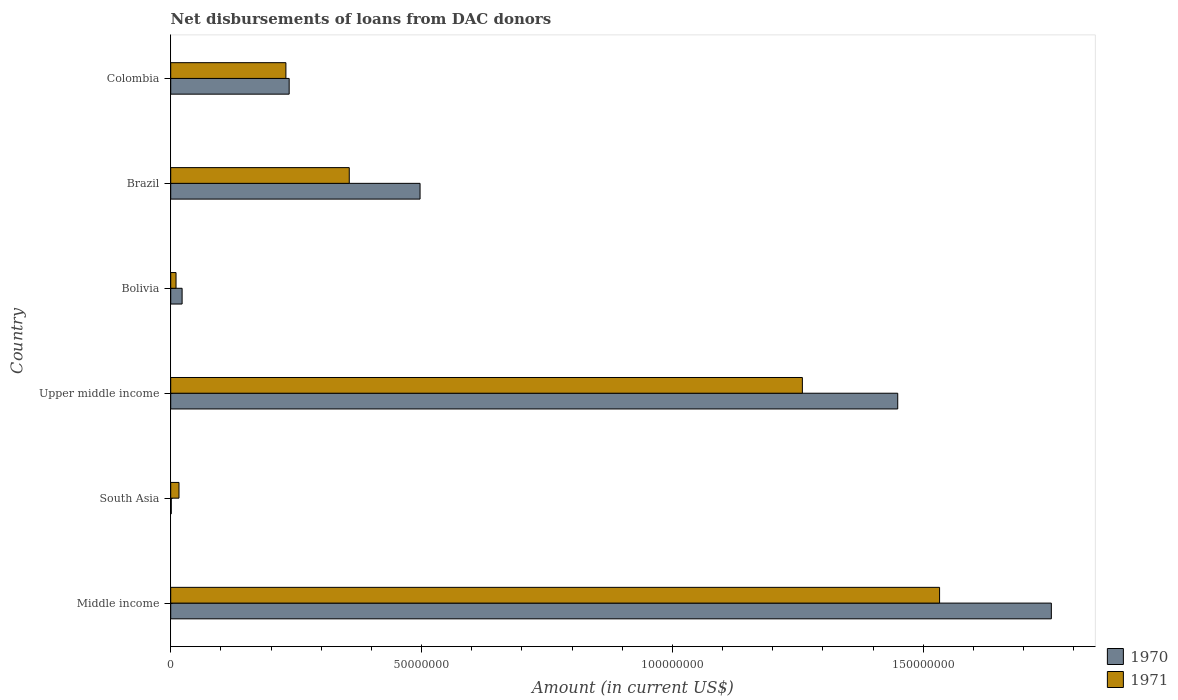How many groups of bars are there?
Offer a very short reply. 6. How many bars are there on the 3rd tick from the top?
Ensure brevity in your answer.  2. How many bars are there on the 1st tick from the bottom?
Provide a short and direct response. 2. What is the amount of loans disbursed in 1970 in South Asia?
Make the answer very short. 1.09e+05. Across all countries, what is the maximum amount of loans disbursed in 1970?
Keep it short and to the point. 1.76e+08. Across all countries, what is the minimum amount of loans disbursed in 1971?
Ensure brevity in your answer.  1.06e+06. What is the total amount of loans disbursed in 1970 in the graph?
Make the answer very short. 3.96e+08. What is the difference between the amount of loans disbursed in 1970 in Brazil and that in Colombia?
Your response must be concise. 2.61e+07. What is the difference between the amount of loans disbursed in 1971 in Brazil and the amount of loans disbursed in 1970 in Upper middle income?
Your answer should be very brief. -1.09e+08. What is the average amount of loans disbursed in 1970 per country?
Offer a terse response. 6.60e+07. What is the difference between the amount of loans disbursed in 1970 and amount of loans disbursed in 1971 in Upper middle income?
Your response must be concise. 1.90e+07. What is the ratio of the amount of loans disbursed in 1971 in Colombia to that in Middle income?
Offer a terse response. 0.15. Is the difference between the amount of loans disbursed in 1970 in Bolivia and Brazil greater than the difference between the amount of loans disbursed in 1971 in Bolivia and Brazil?
Give a very brief answer. No. What is the difference between the highest and the second highest amount of loans disbursed in 1970?
Your response must be concise. 3.06e+07. What is the difference between the highest and the lowest amount of loans disbursed in 1971?
Keep it short and to the point. 1.52e+08. Is the sum of the amount of loans disbursed in 1970 in Bolivia and Colombia greater than the maximum amount of loans disbursed in 1971 across all countries?
Keep it short and to the point. No. Are all the bars in the graph horizontal?
Your answer should be very brief. Yes. How many countries are there in the graph?
Offer a very short reply. 6. What is the difference between two consecutive major ticks on the X-axis?
Your response must be concise. 5.00e+07. Does the graph contain any zero values?
Your answer should be very brief. No. How many legend labels are there?
Offer a terse response. 2. What is the title of the graph?
Your answer should be very brief. Net disbursements of loans from DAC donors. What is the Amount (in current US$) of 1970 in Middle income?
Provide a short and direct response. 1.76e+08. What is the Amount (in current US$) in 1971 in Middle income?
Ensure brevity in your answer.  1.53e+08. What is the Amount (in current US$) of 1970 in South Asia?
Provide a succinct answer. 1.09e+05. What is the Amount (in current US$) in 1971 in South Asia?
Your answer should be compact. 1.65e+06. What is the Amount (in current US$) in 1970 in Upper middle income?
Your answer should be compact. 1.45e+08. What is the Amount (in current US$) of 1971 in Upper middle income?
Your response must be concise. 1.26e+08. What is the Amount (in current US$) in 1970 in Bolivia?
Offer a very short reply. 2.27e+06. What is the Amount (in current US$) of 1971 in Bolivia?
Give a very brief answer. 1.06e+06. What is the Amount (in current US$) in 1970 in Brazil?
Offer a terse response. 4.97e+07. What is the Amount (in current US$) in 1971 in Brazil?
Offer a terse response. 3.56e+07. What is the Amount (in current US$) in 1970 in Colombia?
Give a very brief answer. 2.36e+07. What is the Amount (in current US$) of 1971 in Colombia?
Ensure brevity in your answer.  2.30e+07. Across all countries, what is the maximum Amount (in current US$) in 1970?
Ensure brevity in your answer.  1.76e+08. Across all countries, what is the maximum Amount (in current US$) of 1971?
Keep it short and to the point. 1.53e+08. Across all countries, what is the minimum Amount (in current US$) of 1970?
Offer a very short reply. 1.09e+05. Across all countries, what is the minimum Amount (in current US$) of 1971?
Your answer should be compact. 1.06e+06. What is the total Amount (in current US$) of 1970 in the graph?
Your answer should be very brief. 3.96e+08. What is the total Amount (in current US$) in 1971 in the graph?
Provide a succinct answer. 3.40e+08. What is the difference between the Amount (in current US$) of 1970 in Middle income and that in South Asia?
Give a very brief answer. 1.75e+08. What is the difference between the Amount (in current US$) of 1971 in Middle income and that in South Asia?
Offer a very short reply. 1.52e+08. What is the difference between the Amount (in current US$) in 1970 in Middle income and that in Upper middle income?
Offer a terse response. 3.06e+07. What is the difference between the Amount (in current US$) in 1971 in Middle income and that in Upper middle income?
Give a very brief answer. 2.74e+07. What is the difference between the Amount (in current US$) of 1970 in Middle income and that in Bolivia?
Your answer should be very brief. 1.73e+08. What is the difference between the Amount (in current US$) in 1971 in Middle income and that in Bolivia?
Offer a terse response. 1.52e+08. What is the difference between the Amount (in current US$) of 1970 in Middle income and that in Brazil?
Keep it short and to the point. 1.26e+08. What is the difference between the Amount (in current US$) in 1971 in Middle income and that in Brazil?
Your answer should be compact. 1.18e+08. What is the difference between the Amount (in current US$) in 1970 in Middle income and that in Colombia?
Offer a terse response. 1.52e+08. What is the difference between the Amount (in current US$) of 1971 in Middle income and that in Colombia?
Offer a terse response. 1.30e+08. What is the difference between the Amount (in current US$) of 1970 in South Asia and that in Upper middle income?
Provide a short and direct response. -1.45e+08. What is the difference between the Amount (in current US$) of 1971 in South Asia and that in Upper middle income?
Make the answer very short. -1.24e+08. What is the difference between the Amount (in current US$) in 1970 in South Asia and that in Bolivia?
Keep it short and to the point. -2.16e+06. What is the difference between the Amount (in current US$) in 1971 in South Asia and that in Bolivia?
Give a very brief answer. 5.92e+05. What is the difference between the Amount (in current US$) in 1970 in South Asia and that in Brazil?
Offer a terse response. -4.96e+07. What is the difference between the Amount (in current US$) in 1971 in South Asia and that in Brazil?
Ensure brevity in your answer.  -3.39e+07. What is the difference between the Amount (in current US$) in 1970 in South Asia and that in Colombia?
Ensure brevity in your answer.  -2.35e+07. What is the difference between the Amount (in current US$) of 1971 in South Asia and that in Colombia?
Give a very brief answer. -2.13e+07. What is the difference between the Amount (in current US$) of 1970 in Upper middle income and that in Bolivia?
Your answer should be very brief. 1.43e+08. What is the difference between the Amount (in current US$) of 1971 in Upper middle income and that in Bolivia?
Offer a very short reply. 1.25e+08. What is the difference between the Amount (in current US$) in 1970 in Upper middle income and that in Brazil?
Offer a very short reply. 9.52e+07. What is the difference between the Amount (in current US$) in 1971 in Upper middle income and that in Brazil?
Provide a succinct answer. 9.03e+07. What is the difference between the Amount (in current US$) in 1970 in Upper middle income and that in Colombia?
Your response must be concise. 1.21e+08. What is the difference between the Amount (in current US$) in 1971 in Upper middle income and that in Colombia?
Your response must be concise. 1.03e+08. What is the difference between the Amount (in current US$) of 1970 in Bolivia and that in Brazil?
Provide a short and direct response. -4.74e+07. What is the difference between the Amount (in current US$) in 1971 in Bolivia and that in Brazil?
Provide a short and direct response. -3.45e+07. What is the difference between the Amount (in current US$) in 1970 in Bolivia and that in Colombia?
Provide a succinct answer. -2.13e+07. What is the difference between the Amount (in current US$) of 1971 in Bolivia and that in Colombia?
Offer a very short reply. -2.19e+07. What is the difference between the Amount (in current US$) in 1970 in Brazil and that in Colombia?
Give a very brief answer. 2.61e+07. What is the difference between the Amount (in current US$) of 1971 in Brazil and that in Colombia?
Your response must be concise. 1.26e+07. What is the difference between the Amount (in current US$) in 1970 in Middle income and the Amount (in current US$) in 1971 in South Asia?
Offer a terse response. 1.74e+08. What is the difference between the Amount (in current US$) of 1970 in Middle income and the Amount (in current US$) of 1971 in Upper middle income?
Offer a terse response. 4.96e+07. What is the difference between the Amount (in current US$) in 1970 in Middle income and the Amount (in current US$) in 1971 in Bolivia?
Keep it short and to the point. 1.74e+08. What is the difference between the Amount (in current US$) in 1970 in Middle income and the Amount (in current US$) in 1971 in Brazil?
Your answer should be compact. 1.40e+08. What is the difference between the Amount (in current US$) in 1970 in Middle income and the Amount (in current US$) in 1971 in Colombia?
Your response must be concise. 1.53e+08. What is the difference between the Amount (in current US$) in 1970 in South Asia and the Amount (in current US$) in 1971 in Upper middle income?
Keep it short and to the point. -1.26e+08. What is the difference between the Amount (in current US$) of 1970 in South Asia and the Amount (in current US$) of 1971 in Bolivia?
Make the answer very short. -9.49e+05. What is the difference between the Amount (in current US$) of 1970 in South Asia and the Amount (in current US$) of 1971 in Brazil?
Make the answer very short. -3.55e+07. What is the difference between the Amount (in current US$) of 1970 in South Asia and the Amount (in current US$) of 1971 in Colombia?
Your answer should be compact. -2.29e+07. What is the difference between the Amount (in current US$) in 1970 in Upper middle income and the Amount (in current US$) in 1971 in Bolivia?
Offer a terse response. 1.44e+08. What is the difference between the Amount (in current US$) of 1970 in Upper middle income and the Amount (in current US$) of 1971 in Brazil?
Ensure brevity in your answer.  1.09e+08. What is the difference between the Amount (in current US$) in 1970 in Upper middle income and the Amount (in current US$) in 1971 in Colombia?
Ensure brevity in your answer.  1.22e+08. What is the difference between the Amount (in current US$) in 1970 in Bolivia and the Amount (in current US$) in 1971 in Brazil?
Provide a succinct answer. -3.33e+07. What is the difference between the Amount (in current US$) of 1970 in Bolivia and the Amount (in current US$) of 1971 in Colombia?
Provide a short and direct response. -2.07e+07. What is the difference between the Amount (in current US$) of 1970 in Brazil and the Amount (in current US$) of 1971 in Colombia?
Your answer should be compact. 2.67e+07. What is the average Amount (in current US$) of 1970 per country?
Your answer should be compact. 6.60e+07. What is the average Amount (in current US$) of 1971 per country?
Give a very brief answer. 5.67e+07. What is the difference between the Amount (in current US$) of 1970 and Amount (in current US$) of 1971 in Middle income?
Your answer should be compact. 2.23e+07. What is the difference between the Amount (in current US$) in 1970 and Amount (in current US$) in 1971 in South Asia?
Offer a very short reply. -1.54e+06. What is the difference between the Amount (in current US$) of 1970 and Amount (in current US$) of 1971 in Upper middle income?
Give a very brief answer. 1.90e+07. What is the difference between the Amount (in current US$) in 1970 and Amount (in current US$) in 1971 in Bolivia?
Offer a very short reply. 1.21e+06. What is the difference between the Amount (in current US$) in 1970 and Amount (in current US$) in 1971 in Brazil?
Your answer should be compact. 1.41e+07. What is the difference between the Amount (in current US$) of 1970 and Amount (in current US$) of 1971 in Colombia?
Keep it short and to the point. 6.52e+05. What is the ratio of the Amount (in current US$) of 1970 in Middle income to that in South Asia?
Offer a terse response. 1610.58. What is the ratio of the Amount (in current US$) in 1971 in Middle income to that in South Asia?
Offer a terse response. 92.89. What is the ratio of the Amount (in current US$) of 1970 in Middle income to that in Upper middle income?
Ensure brevity in your answer.  1.21. What is the ratio of the Amount (in current US$) in 1971 in Middle income to that in Upper middle income?
Your answer should be very brief. 1.22. What is the ratio of the Amount (in current US$) of 1970 in Middle income to that in Bolivia?
Make the answer very short. 77.34. What is the ratio of the Amount (in current US$) of 1971 in Middle income to that in Bolivia?
Provide a short and direct response. 144.87. What is the ratio of the Amount (in current US$) of 1970 in Middle income to that in Brazil?
Provide a succinct answer. 3.53. What is the ratio of the Amount (in current US$) of 1971 in Middle income to that in Brazil?
Your response must be concise. 4.31. What is the ratio of the Amount (in current US$) in 1970 in Middle income to that in Colombia?
Provide a short and direct response. 7.43. What is the ratio of the Amount (in current US$) of 1971 in Middle income to that in Colombia?
Make the answer very short. 6.67. What is the ratio of the Amount (in current US$) in 1970 in South Asia to that in Upper middle income?
Your answer should be very brief. 0. What is the ratio of the Amount (in current US$) in 1971 in South Asia to that in Upper middle income?
Provide a short and direct response. 0.01. What is the ratio of the Amount (in current US$) in 1970 in South Asia to that in Bolivia?
Your answer should be compact. 0.05. What is the ratio of the Amount (in current US$) of 1971 in South Asia to that in Bolivia?
Ensure brevity in your answer.  1.56. What is the ratio of the Amount (in current US$) in 1970 in South Asia to that in Brazil?
Offer a terse response. 0. What is the ratio of the Amount (in current US$) in 1971 in South Asia to that in Brazil?
Provide a short and direct response. 0.05. What is the ratio of the Amount (in current US$) of 1970 in South Asia to that in Colombia?
Keep it short and to the point. 0. What is the ratio of the Amount (in current US$) in 1971 in South Asia to that in Colombia?
Ensure brevity in your answer.  0.07. What is the ratio of the Amount (in current US$) in 1970 in Upper middle income to that in Bolivia?
Ensure brevity in your answer.  63.85. What is the ratio of the Amount (in current US$) in 1971 in Upper middle income to that in Bolivia?
Provide a short and direct response. 119.02. What is the ratio of the Amount (in current US$) of 1970 in Upper middle income to that in Brazil?
Make the answer very short. 2.92. What is the ratio of the Amount (in current US$) in 1971 in Upper middle income to that in Brazil?
Ensure brevity in your answer.  3.54. What is the ratio of the Amount (in current US$) of 1970 in Upper middle income to that in Colombia?
Provide a succinct answer. 6.14. What is the ratio of the Amount (in current US$) in 1971 in Upper middle income to that in Colombia?
Make the answer very short. 5.48. What is the ratio of the Amount (in current US$) in 1970 in Bolivia to that in Brazil?
Your response must be concise. 0.05. What is the ratio of the Amount (in current US$) of 1971 in Bolivia to that in Brazil?
Offer a very short reply. 0.03. What is the ratio of the Amount (in current US$) in 1970 in Bolivia to that in Colombia?
Provide a succinct answer. 0.1. What is the ratio of the Amount (in current US$) of 1971 in Bolivia to that in Colombia?
Provide a short and direct response. 0.05. What is the ratio of the Amount (in current US$) of 1970 in Brazil to that in Colombia?
Offer a terse response. 2.1. What is the ratio of the Amount (in current US$) of 1971 in Brazil to that in Colombia?
Offer a very short reply. 1.55. What is the difference between the highest and the second highest Amount (in current US$) in 1970?
Ensure brevity in your answer.  3.06e+07. What is the difference between the highest and the second highest Amount (in current US$) in 1971?
Offer a terse response. 2.74e+07. What is the difference between the highest and the lowest Amount (in current US$) in 1970?
Ensure brevity in your answer.  1.75e+08. What is the difference between the highest and the lowest Amount (in current US$) of 1971?
Your answer should be very brief. 1.52e+08. 